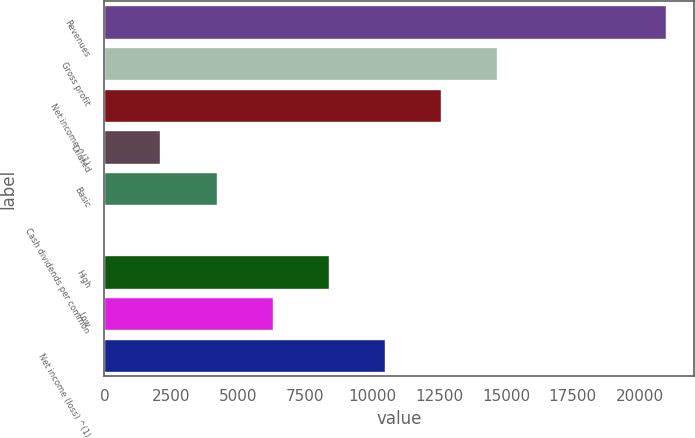Convert chart to OTSL. <chart><loc_0><loc_0><loc_500><loc_500><bar_chart><fcel>Revenues<fcel>Gross profit<fcel>Net income ^(1)<fcel>Diluted<fcel>Basic<fcel>Cash dividends per common<fcel>High<fcel>Low<fcel>Net income (loss) ^(1)<nl><fcel>20968<fcel>14677.6<fcel>12580.8<fcel>2096.85<fcel>4193.64<fcel>0.06<fcel>8387.22<fcel>6290.43<fcel>10484<nl></chart> 